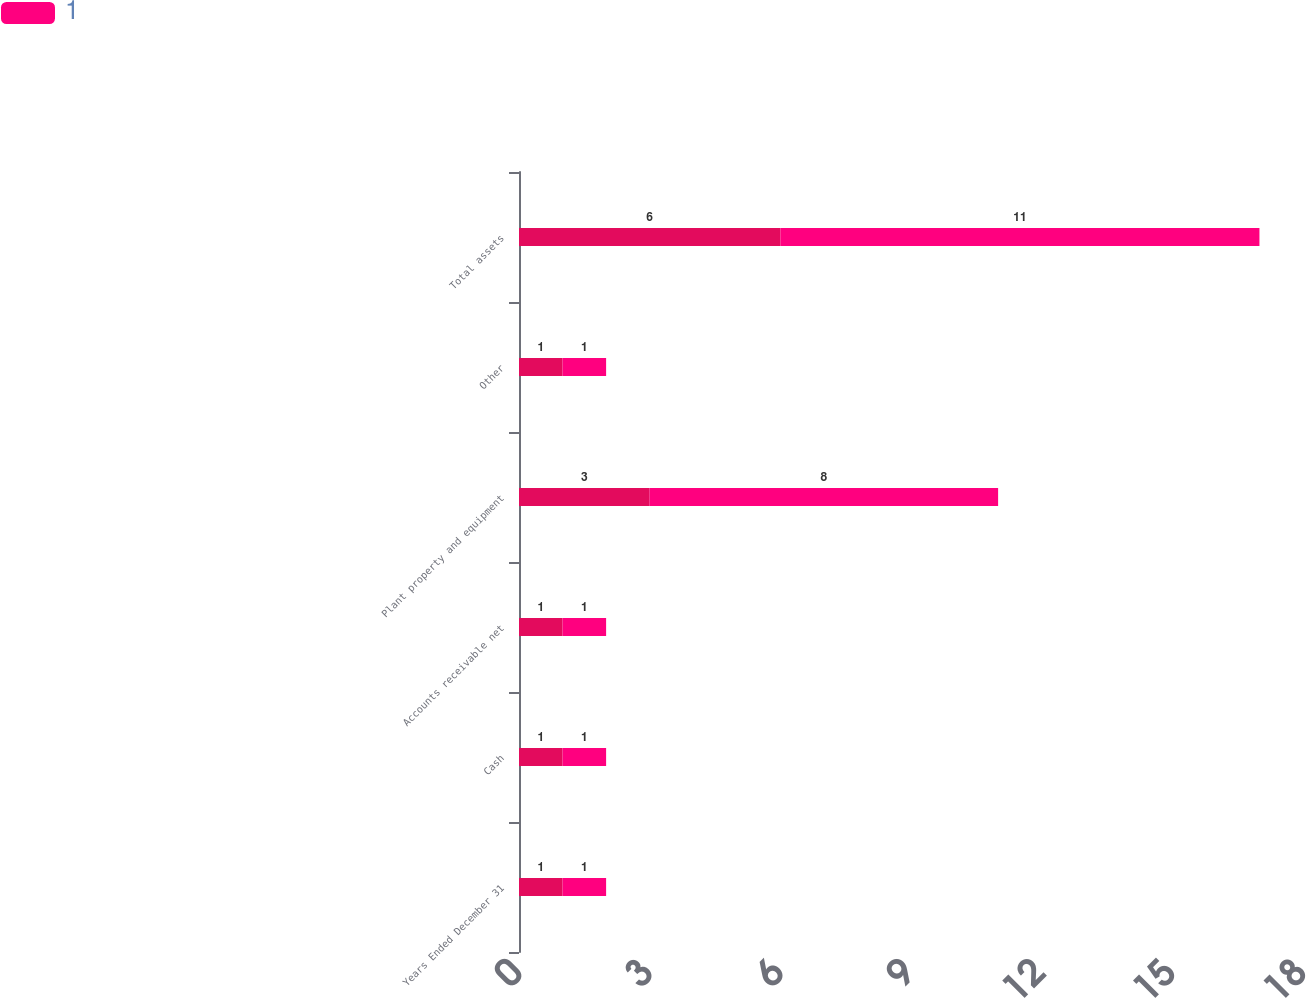Convert chart. <chart><loc_0><loc_0><loc_500><loc_500><stacked_bar_chart><ecel><fcel>Years Ended December 31<fcel>Cash<fcel>Accounts receivable net<fcel>Plant property and equipment<fcel>Other<fcel>Total assets<nl><fcel>nan<fcel>1<fcel>1<fcel>1<fcel>3<fcel>1<fcel>6<nl><fcel>1<fcel>1<fcel>1<fcel>1<fcel>8<fcel>1<fcel>11<nl></chart> 